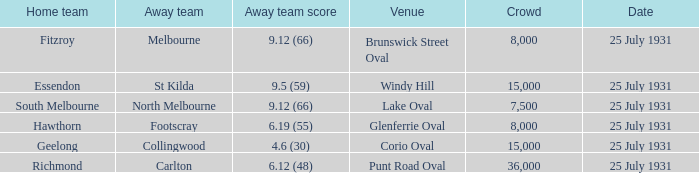When the home team was fitzroy, what did the away team score? 9.12 (66). 